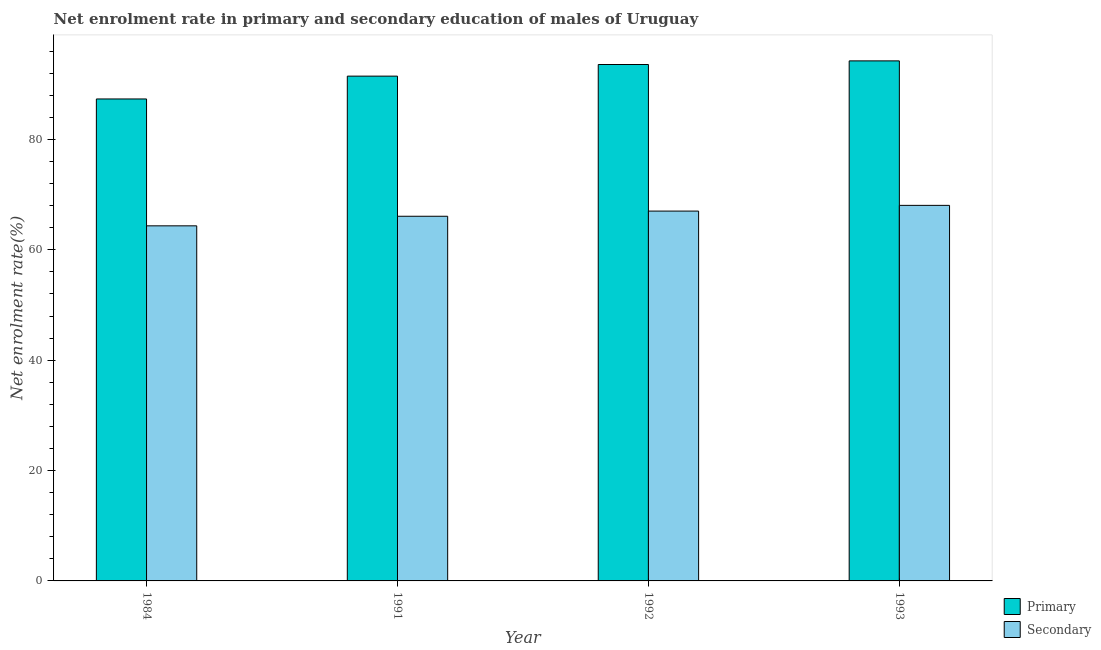What is the label of the 1st group of bars from the left?
Offer a terse response. 1984. What is the enrollment rate in secondary education in 1993?
Ensure brevity in your answer.  68.05. Across all years, what is the maximum enrollment rate in secondary education?
Offer a very short reply. 68.05. Across all years, what is the minimum enrollment rate in primary education?
Give a very brief answer. 87.33. In which year was the enrollment rate in secondary education minimum?
Give a very brief answer. 1984. What is the total enrollment rate in primary education in the graph?
Keep it short and to the point. 366.62. What is the difference between the enrollment rate in secondary education in 1991 and that in 1993?
Your answer should be compact. -1.97. What is the difference between the enrollment rate in secondary education in 1984 and the enrollment rate in primary education in 1993?
Make the answer very short. -3.71. What is the average enrollment rate in primary education per year?
Offer a very short reply. 91.65. In the year 1991, what is the difference between the enrollment rate in secondary education and enrollment rate in primary education?
Make the answer very short. 0. What is the ratio of the enrollment rate in secondary education in 1984 to that in 1992?
Ensure brevity in your answer.  0.96. Is the enrollment rate in secondary education in 1984 less than that in 1992?
Provide a succinct answer. Yes. What is the difference between the highest and the second highest enrollment rate in secondary education?
Ensure brevity in your answer.  1.04. What is the difference between the highest and the lowest enrollment rate in primary education?
Your response must be concise. 6.9. In how many years, is the enrollment rate in primary education greater than the average enrollment rate in primary education taken over all years?
Keep it short and to the point. 2. What does the 2nd bar from the left in 1993 represents?
Offer a very short reply. Secondary. What does the 2nd bar from the right in 1992 represents?
Your answer should be very brief. Primary. Are all the bars in the graph horizontal?
Your answer should be very brief. No. How many years are there in the graph?
Your answer should be very brief. 4. Are the values on the major ticks of Y-axis written in scientific E-notation?
Ensure brevity in your answer.  No. What is the title of the graph?
Give a very brief answer. Net enrolment rate in primary and secondary education of males of Uruguay. What is the label or title of the X-axis?
Provide a short and direct response. Year. What is the label or title of the Y-axis?
Offer a terse response. Net enrolment rate(%). What is the Net enrolment rate(%) in Primary in 1984?
Give a very brief answer. 87.33. What is the Net enrolment rate(%) of Secondary in 1984?
Your response must be concise. 64.35. What is the Net enrolment rate(%) of Primary in 1991?
Your answer should be compact. 91.47. What is the Net enrolment rate(%) in Secondary in 1991?
Offer a very short reply. 66.08. What is the Net enrolment rate(%) in Primary in 1992?
Offer a terse response. 93.58. What is the Net enrolment rate(%) in Secondary in 1992?
Keep it short and to the point. 67.02. What is the Net enrolment rate(%) in Primary in 1993?
Give a very brief answer. 94.24. What is the Net enrolment rate(%) in Secondary in 1993?
Offer a very short reply. 68.05. Across all years, what is the maximum Net enrolment rate(%) of Primary?
Your answer should be compact. 94.24. Across all years, what is the maximum Net enrolment rate(%) in Secondary?
Give a very brief answer. 68.05. Across all years, what is the minimum Net enrolment rate(%) in Primary?
Your answer should be very brief. 87.33. Across all years, what is the minimum Net enrolment rate(%) of Secondary?
Offer a very short reply. 64.35. What is the total Net enrolment rate(%) of Primary in the graph?
Provide a succinct answer. 366.62. What is the total Net enrolment rate(%) of Secondary in the graph?
Give a very brief answer. 265.49. What is the difference between the Net enrolment rate(%) in Primary in 1984 and that in 1991?
Your answer should be very brief. -4.14. What is the difference between the Net enrolment rate(%) of Secondary in 1984 and that in 1991?
Your answer should be compact. -1.73. What is the difference between the Net enrolment rate(%) of Primary in 1984 and that in 1992?
Ensure brevity in your answer.  -6.24. What is the difference between the Net enrolment rate(%) in Secondary in 1984 and that in 1992?
Offer a very short reply. -2.67. What is the difference between the Net enrolment rate(%) of Primary in 1984 and that in 1993?
Your response must be concise. -6.9. What is the difference between the Net enrolment rate(%) of Secondary in 1984 and that in 1993?
Make the answer very short. -3.71. What is the difference between the Net enrolment rate(%) in Primary in 1991 and that in 1992?
Ensure brevity in your answer.  -2.1. What is the difference between the Net enrolment rate(%) of Secondary in 1991 and that in 1992?
Your answer should be very brief. -0.94. What is the difference between the Net enrolment rate(%) of Primary in 1991 and that in 1993?
Make the answer very short. -2.76. What is the difference between the Net enrolment rate(%) in Secondary in 1991 and that in 1993?
Give a very brief answer. -1.97. What is the difference between the Net enrolment rate(%) in Primary in 1992 and that in 1993?
Ensure brevity in your answer.  -0.66. What is the difference between the Net enrolment rate(%) in Secondary in 1992 and that in 1993?
Your response must be concise. -1.04. What is the difference between the Net enrolment rate(%) of Primary in 1984 and the Net enrolment rate(%) of Secondary in 1991?
Keep it short and to the point. 21.25. What is the difference between the Net enrolment rate(%) in Primary in 1984 and the Net enrolment rate(%) in Secondary in 1992?
Offer a very short reply. 20.32. What is the difference between the Net enrolment rate(%) of Primary in 1984 and the Net enrolment rate(%) of Secondary in 1993?
Your answer should be very brief. 19.28. What is the difference between the Net enrolment rate(%) in Primary in 1991 and the Net enrolment rate(%) in Secondary in 1992?
Offer a very short reply. 24.46. What is the difference between the Net enrolment rate(%) of Primary in 1991 and the Net enrolment rate(%) of Secondary in 1993?
Your answer should be compact. 23.42. What is the difference between the Net enrolment rate(%) of Primary in 1992 and the Net enrolment rate(%) of Secondary in 1993?
Your response must be concise. 25.53. What is the average Net enrolment rate(%) in Primary per year?
Your answer should be compact. 91.65. What is the average Net enrolment rate(%) of Secondary per year?
Your answer should be compact. 66.37. In the year 1984, what is the difference between the Net enrolment rate(%) in Primary and Net enrolment rate(%) in Secondary?
Give a very brief answer. 22.99. In the year 1991, what is the difference between the Net enrolment rate(%) in Primary and Net enrolment rate(%) in Secondary?
Your answer should be very brief. 25.39. In the year 1992, what is the difference between the Net enrolment rate(%) of Primary and Net enrolment rate(%) of Secondary?
Offer a terse response. 26.56. In the year 1993, what is the difference between the Net enrolment rate(%) of Primary and Net enrolment rate(%) of Secondary?
Your answer should be very brief. 26.18. What is the ratio of the Net enrolment rate(%) of Primary in 1984 to that in 1991?
Ensure brevity in your answer.  0.95. What is the ratio of the Net enrolment rate(%) in Secondary in 1984 to that in 1991?
Your answer should be very brief. 0.97. What is the ratio of the Net enrolment rate(%) of Primary in 1984 to that in 1992?
Make the answer very short. 0.93. What is the ratio of the Net enrolment rate(%) in Secondary in 1984 to that in 1992?
Offer a very short reply. 0.96. What is the ratio of the Net enrolment rate(%) of Primary in 1984 to that in 1993?
Offer a terse response. 0.93. What is the ratio of the Net enrolment rate(%) of Secondary in 1984 to that in 1993?
Your answer should be very brief. 0.95. What is the ratio of the Net enrolment rate(%) of Primary in 1991 to that in 1992?
Provide a succinct answer. 0.98. What is the ratio of the Net enrolment rate(%) in Secondary in 1991 to that in 1992?
Your answer should be very brief. 0.99. What is the ratio of the Net enrolment rate(%) in Primary in 1991 to that in 1993?
Your answer should be compact. 0.97. What is the ratio of the Net enrolment rate(%) of Secondary in 1991 to that in 1993?
Ensure brevity in your answer.  0.97. What is the ratio of the Net enrolment rate(%) of Secondary in 1992 to that in 1993?
Make the answer very short. 0.98. What is the difference between the highest and the second highest Net enrolment rate(%) in Primary?
Your response must be concise. 0.66. What is the difference between the highest and the second highest Net enrolment rate(%) in Secondary?
Your answer should be compact. 1.04. What is the difference between the highest and the lowest Net enrolment rate(%) in Primary?
Your answer should be very brief. 6.9. What is the difference between the highest and the lowest Net enrolment rate(%) in Secondary?
Give a very brief answer. 3.71. 